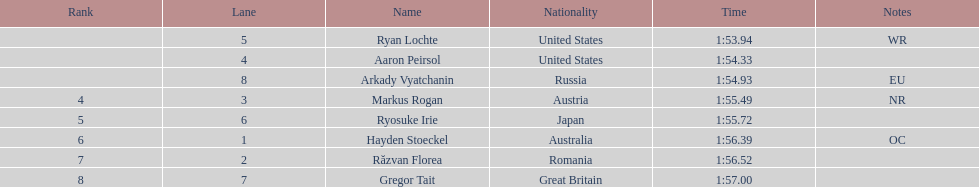Who are the swimmers? Ryan Lochte, Aaron Peirsol, Arkady Vyatchanin, Markus Rogan, Ryosuke Irie, Hayden Stoeckel, Răzvan Florea, Gregor Tait. What is ryosuke irie's time? 1:55.72. 